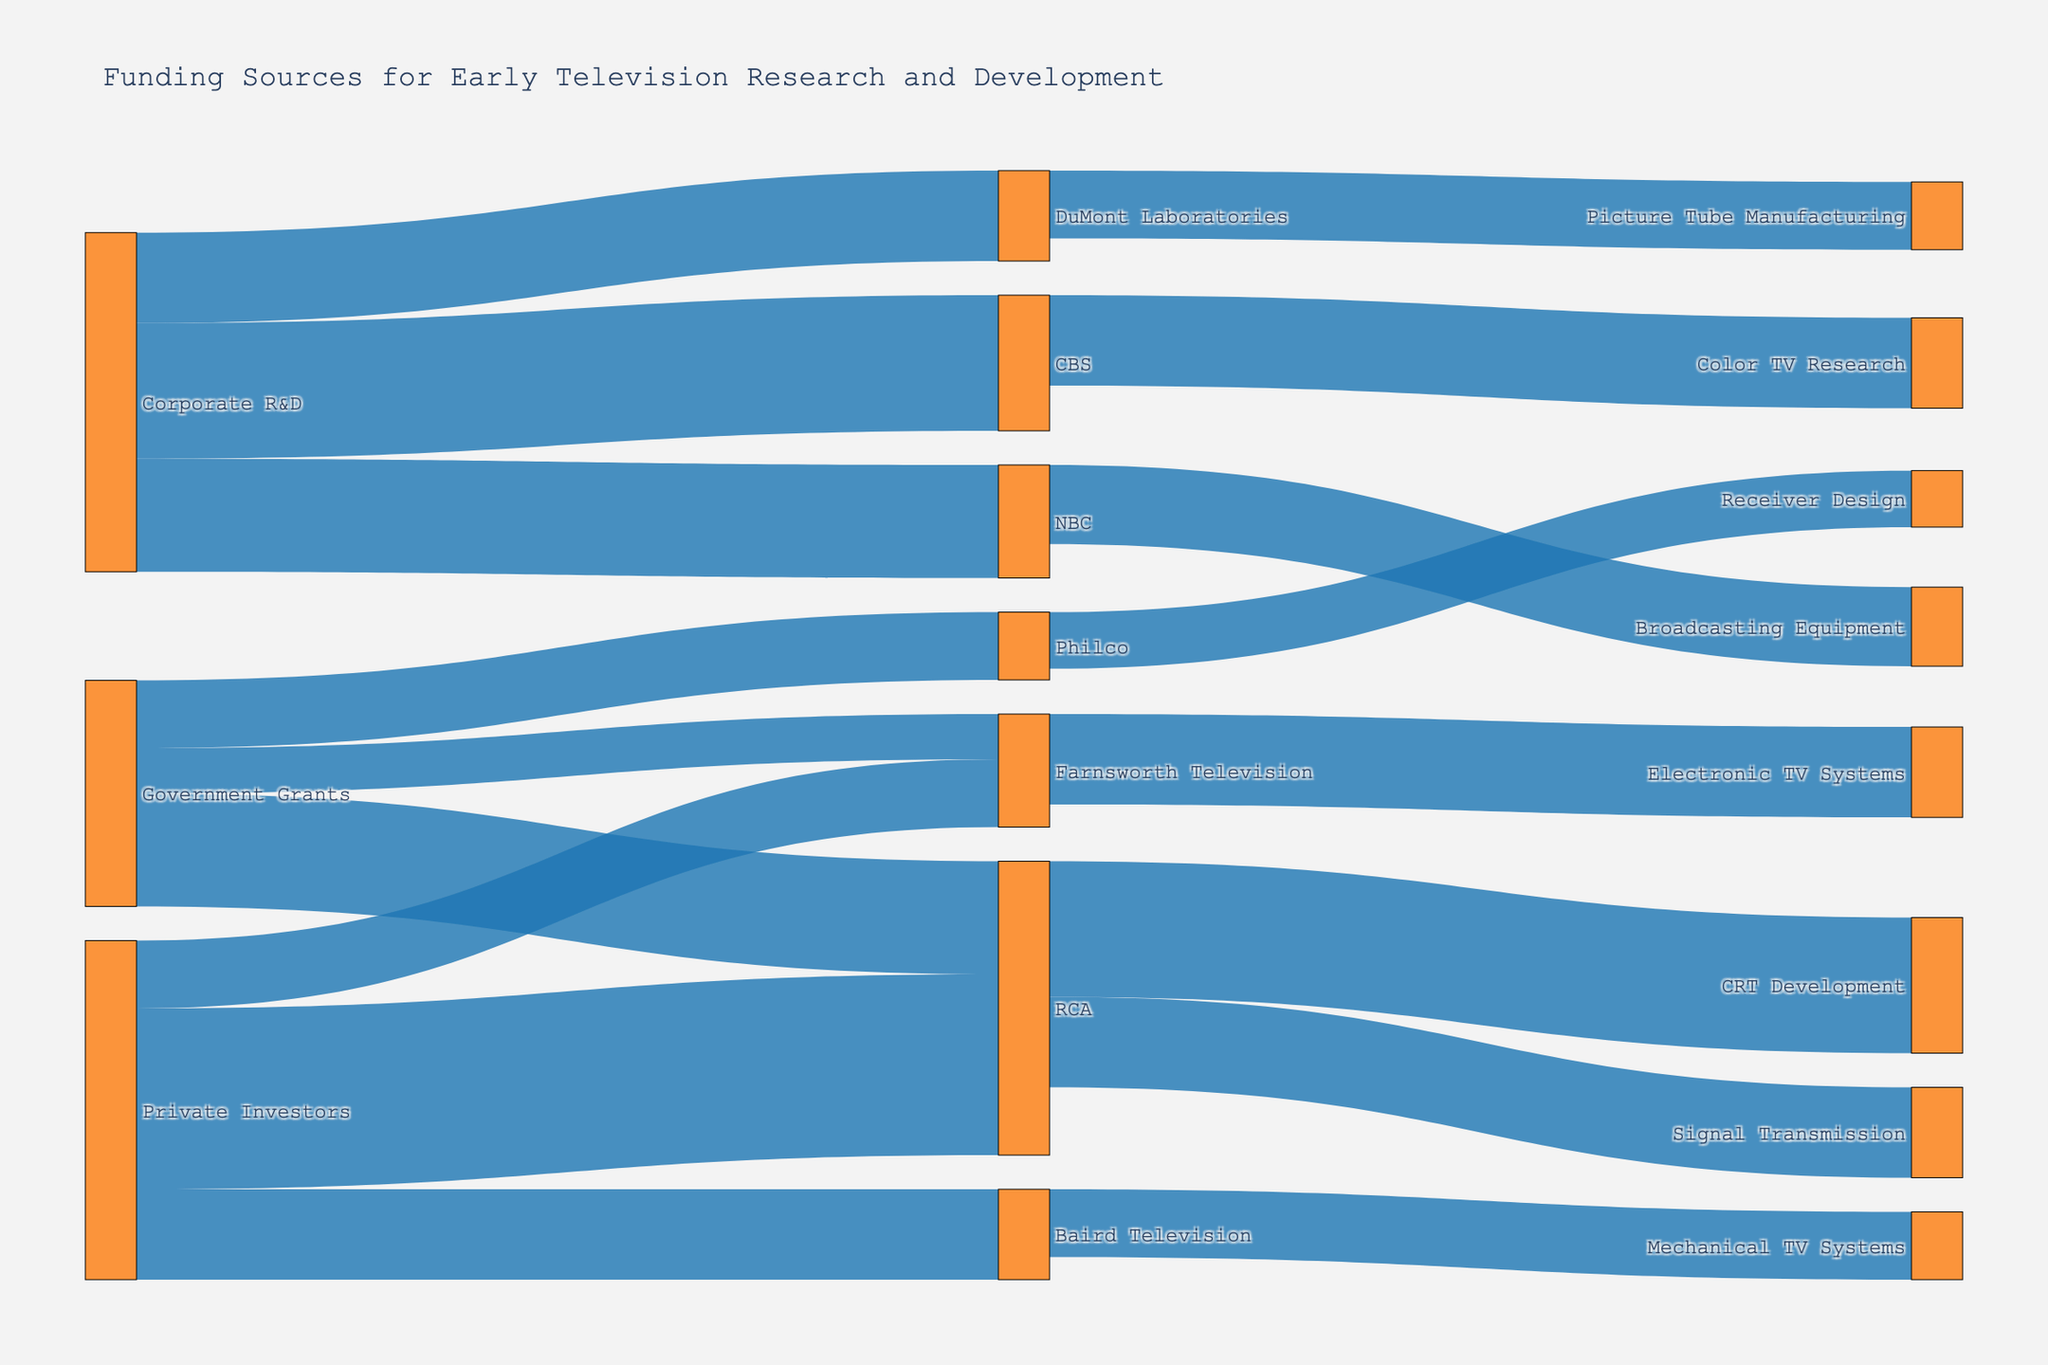Which organization received the most funding from Private Investors? From the diagram, see which organization on the right side has the thickest connection line coming from the "Private Investors" node on the left.
Answer: RCA What's the total amount of funding received from Government Grants? Sum the values of all connections coming from the "Government Grants" node: 5,000,000 (RCA) + 3,000,000 (Philco) + 2,000,000 (Farnsworth Television).
Answer: 10,000,000 How much funding did RCA allocate to Signal Transmission? Look for the connection line between the "RCA" node and the "Signal Transmission" node. The value on the line shows the amount.
Answer: 4,000,000 Which organizations benefited from Corporate R&D funding? Identify the nodes on the right side that are connected to the "Corporate R&D" node.
Answer: CBS, NBC, DuMont Laboratories Is the funding for Mechanical TV Systems from Baird Television higher than the funding for Electronic TV Systems from Farnsworth Television? Compare the values of the connections "Baird Television -> Mechanical TV Systems" (3,000,000) and "Farnsworth Television -> Electronic TV Systems" (4,000,000).
Answer: No What is the total amount of funding received by Farnsworth Television? Sum the values of all connections leading to "Farnsworth Television": 2,000,000 (Government Grants) + 3,000,000 (Private Investors).
Answer: 5,000,000 Which sector is the largest single donor to RCA? Compare the values of the connections "Government Grants -> RCA" (5,000,000) and "Private Investors -> RCA" (8,000,000).
Answer: Private Investors What's the sum of funding allocated to Color TV Research and Broadcasting Equipment? Sum the values "CBS -> Color TV Research" (4,000,000) and "NBC -> Broadcasting Equipment" (3,500,000).
Answer: 7,500,000 How does the funding for Picture Tube Manufacturing from DuMont Laboratories compare to Receiver Design from Philco? Compare the values of "DuMont Laboratories -> Picture Tube Manufacturing" (3,000,000) and "Philco -> Receiver Design" (2,500,000).
Answer: Greater Which organization allocated funding to CRT Development? Look for the node connected to "CRT Development" and find the original source node on the left side.
Answer: RCA 